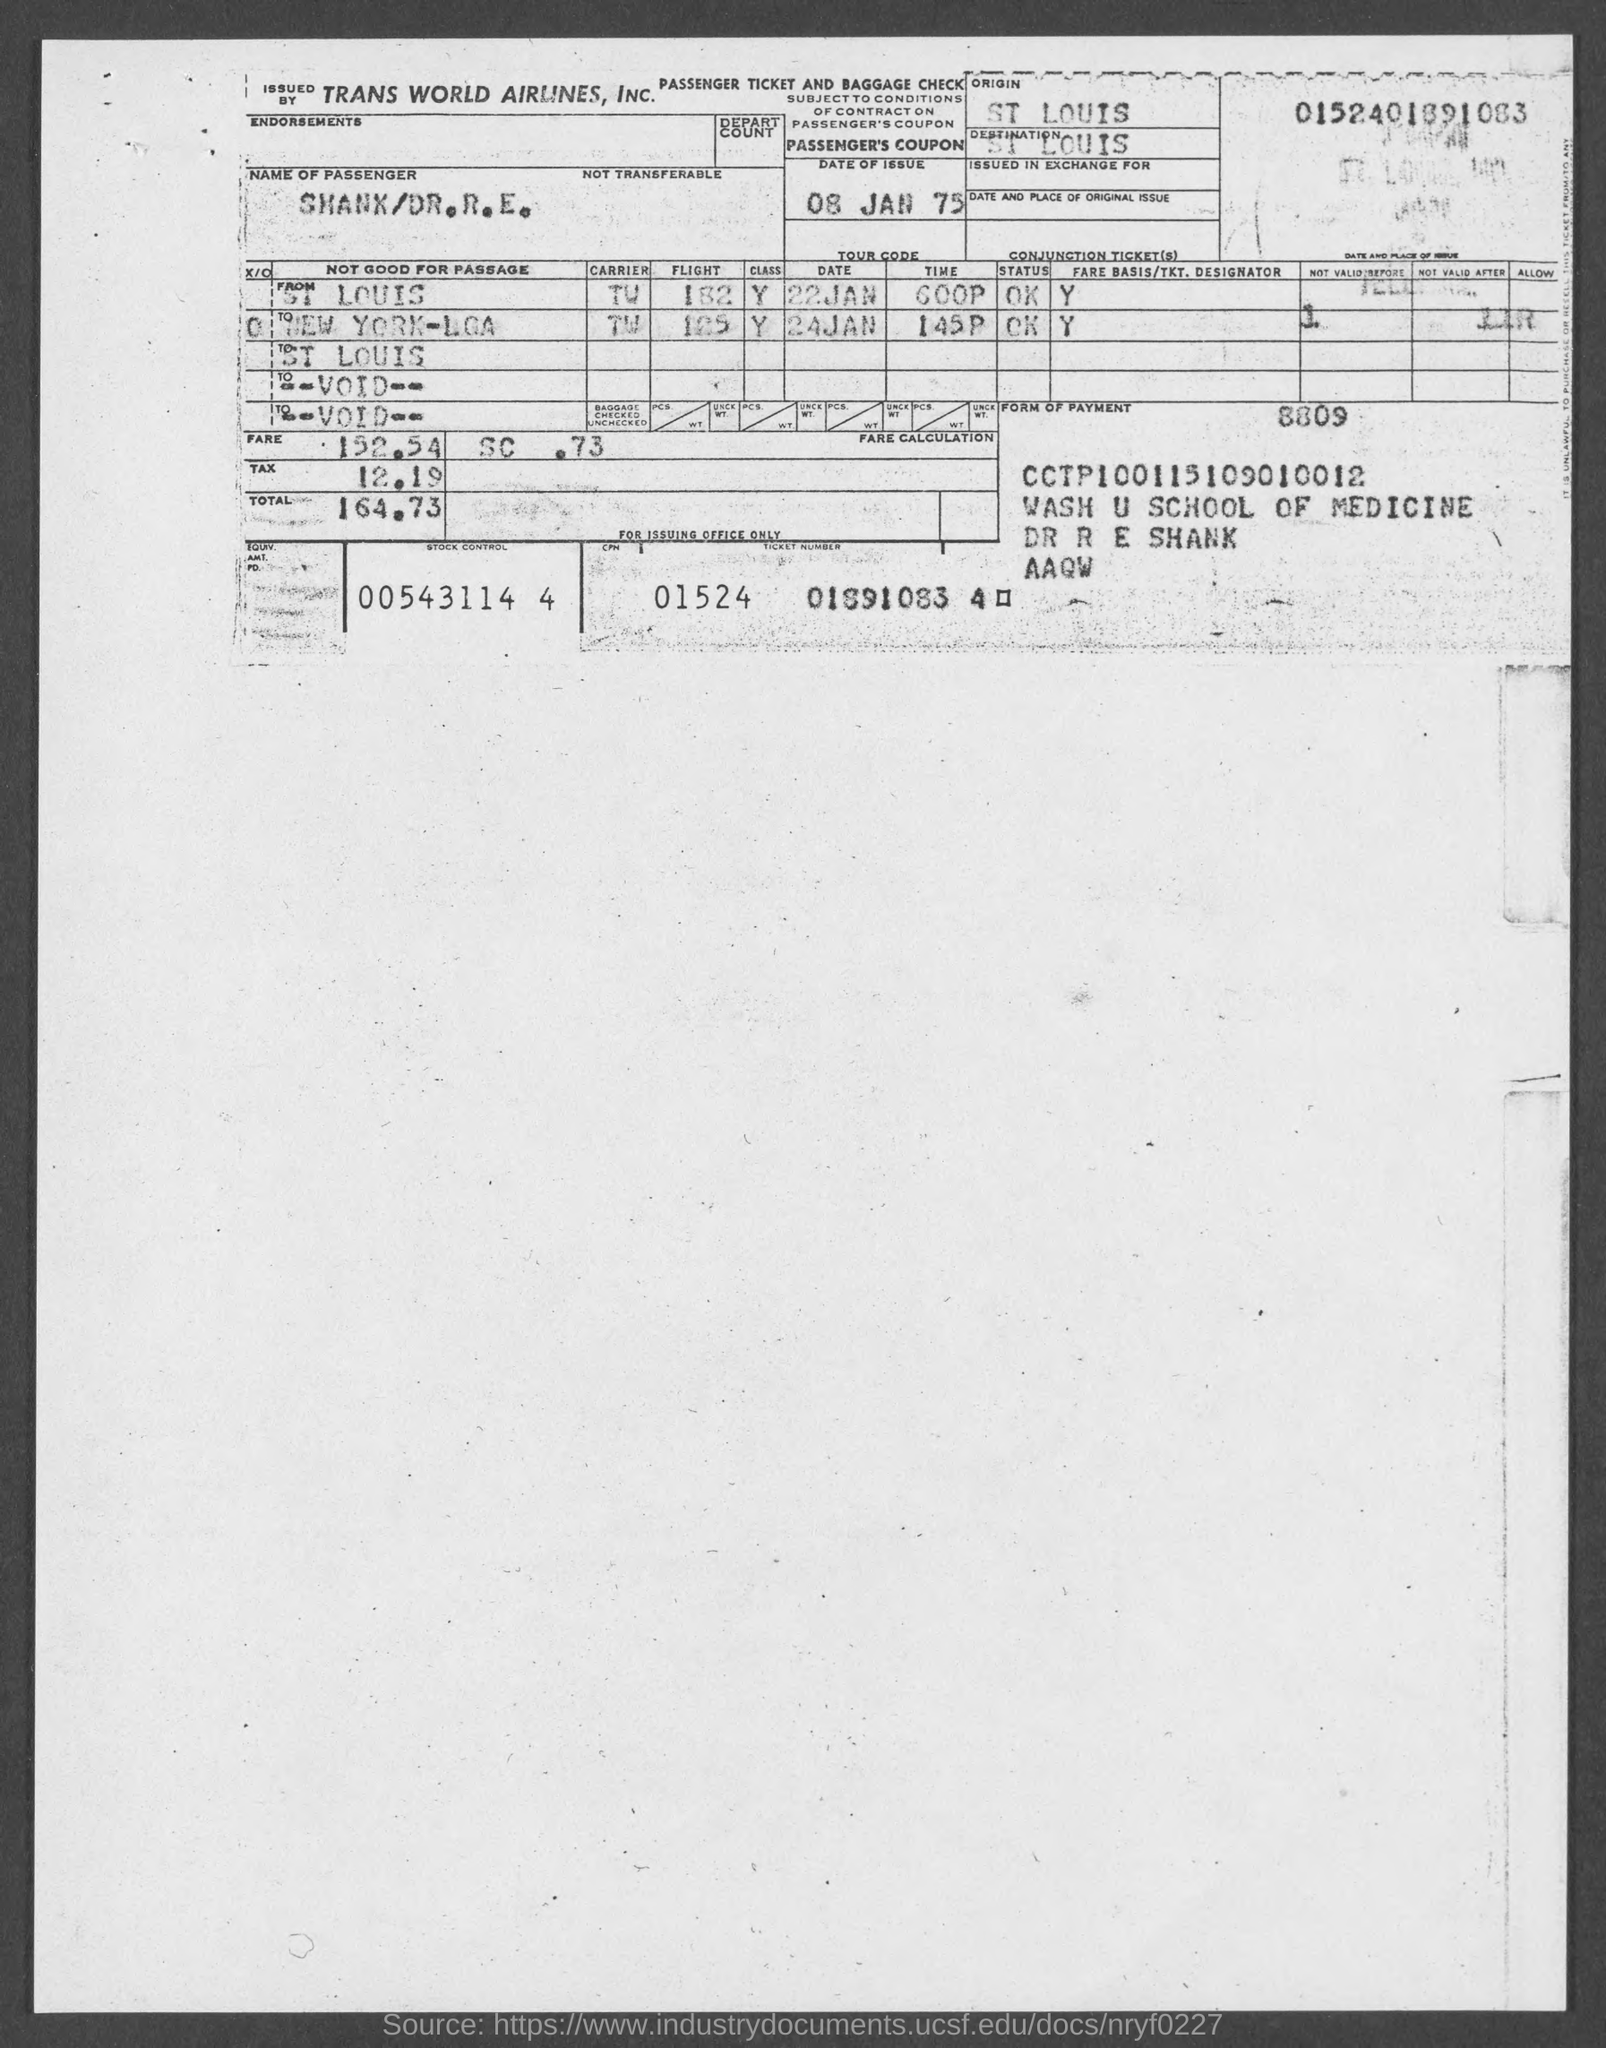Give some essential details in this illustration. The amount of fare mentioned in the given form is 152.54. The stock control number mentioned in the given page is 005431144. The date of issue mentioned in the given page is January 8, 1975. The origin mentioned in the given form is ST LOUIS. The amount of tax mentioned in the given form is 12.19... 